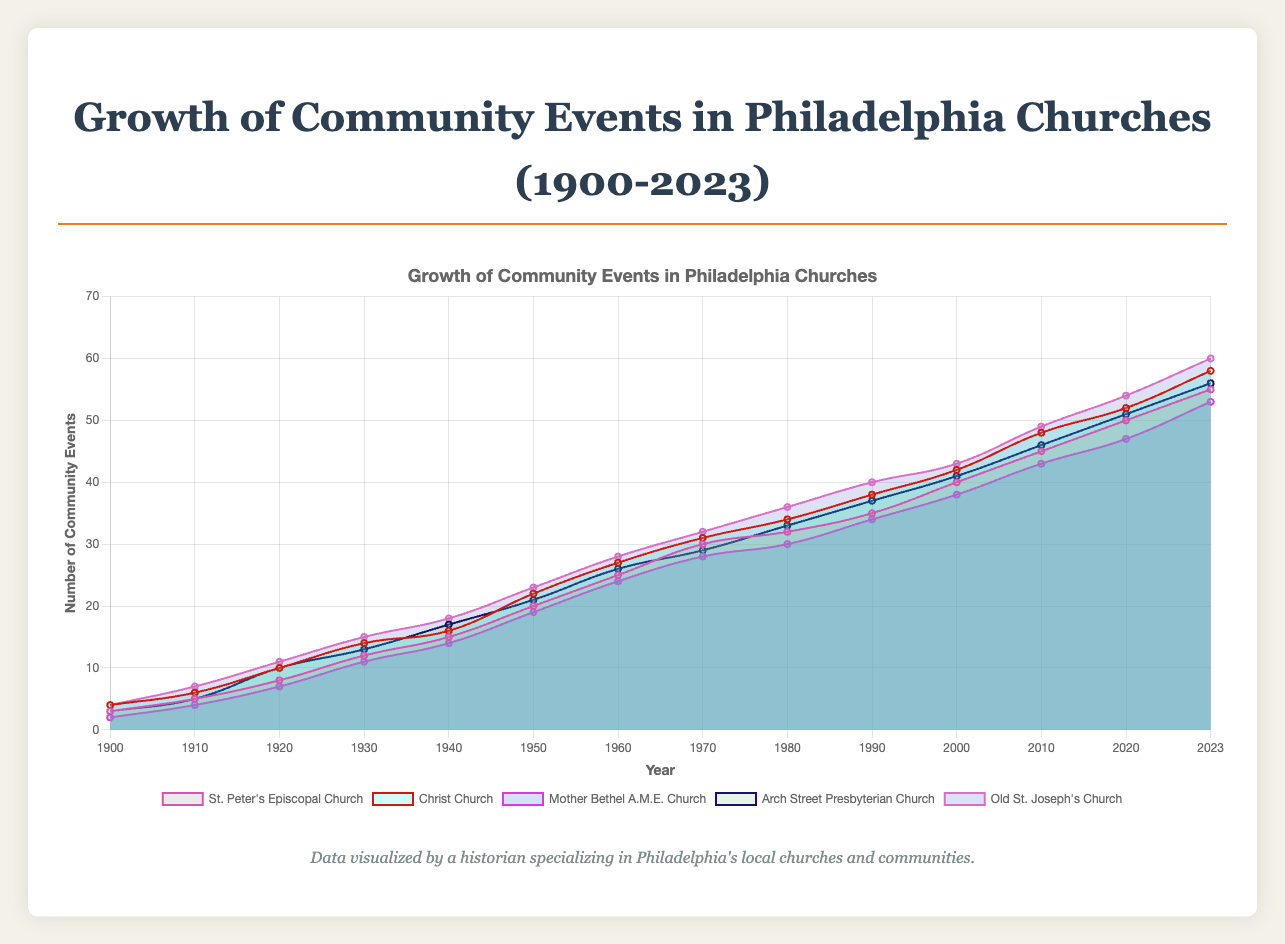What is the title of the chart? The title of the chart is displayed at the top and reads "Growth of Community Events in Philadelphia Churches (1900-2023)"
Answer: Growth of Community Events in Philadelphia Churches (1900-2023) Which church had the most community events in 2023? To find the church with the most community events in 2023, look at the data points for the year 2023 and identify which church has the highest value.
Answer: Old St. Joseph's Church How many community events did Christ Church have in 1950? Locate the data point for Christ Church in the year 1950 on the chart and read off the corresponding value.
Answer: 22 By how much did the number of community events at Mother Bethel A.M.E. Church increase from 1900 to 2023? Subtract the number of events in 1900 from the number of events in 2023 for Mother Bethel A.M.E. Church. That is, \(53 - 2\).
Answer: 51 What is the trend in the number of community events for St. Peter's Episcopal Church from 1900 to 2023? Observe the line representing St. Peter's Episcopal Church from 1900 to 2023; it consistently rises, indicating a steady increase in community events.
Answer: Steady increase Compare the number of community events between Arch Street Presbyterian Church and Christ Church in 1970. Which church had more events? Find the data points for Arch Street Presbyterian Church and Christ Church in 1970 and compare the values.
Answer: Christ Church What was the average number of community events for Old St. Joseph's Church between 1900 and 2023? Sum the number of events for Old St. Joseph's Church across the years and divide by the number of data points (14). That is, \((4 + 7 + 11 + 15 + 18 + 23 + 28 + 32 + 36 + 40 + 43 + 49 + 54 + 60)/14\).
Answer: 30.5 Which church showed the most dramatic increase in community events between 2000 and 2023? Compare the increase in community events from 2000 to 2023 for all churches. The one with the highest difference is the church with the most dramatic increase.
Answer: Old St. Joseph's Church What was the overall trend in community events for the churches from 1900 to 2023? Observe all the lines representing each church from 1900 to 2023; all show an upward trend, indicating an overall increase in community events among the churches.
Answer: Overall increase 